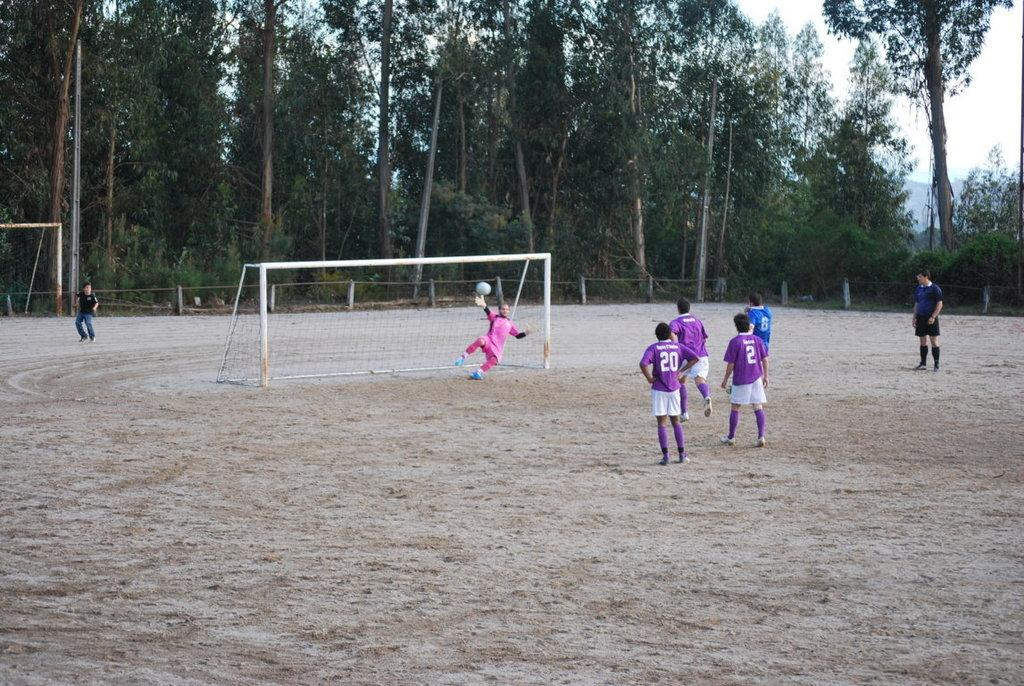<image>
Share a concise interpretation of the image provided. People playing soccer, some with purple jerseys, with one having 20 on the back and the other having 2. 